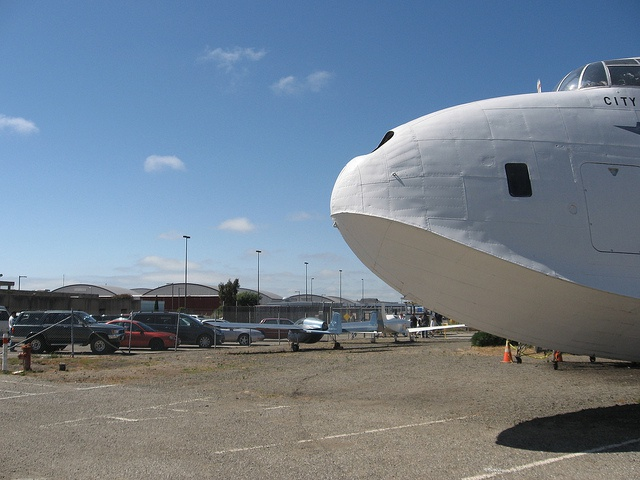Describe the objects in this image and their specific colors. I can see airplane in gray, darkgray, and lightgray tones, truck in gray, black, and blue tones, airplane in gray and black tones, car in gray, black, and blue tones, and car in gray, black, maroon, and brown tones in this image. 